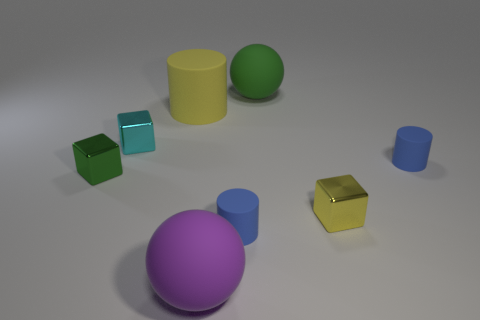Subtract all blue cylinders. How many were subtracted if there are1blue cylinders left? 1 Subtract all tiny cyan blocks. How many blocks are left? 2 Subtract all spheres. How many objects are left? 6 Subtract 1 cylinders. How many cylinders are left? 2 Subtract all red balls. Subtract all red cylinders. How many balls are left? 2 Subtract all cyan cylinders. How many purple cubes are left? 0 Subtract all rubber cylinders. Subtract all big green balls. How many objects are left? 4 Add 6 big rubber cylinders. How many big rubber cylinders are left? 7 Add 4 blue spheres. How many blue spheres exist? 4 Add 2 small red metal blocks. How many objects exist? 10 